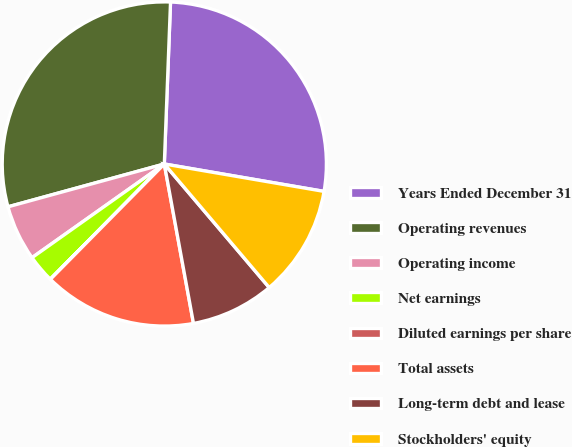<chart> <loc_0><loc_0><loc_500><loc_500><pie_chart><fcel>Years Ended December 31<fcel>Operating revenues<fcel>Operating income<fcel>Net earnings<fcel>Diluted earnings per share<fcel>Total assets<fcel>Long-term debt and lease<fcel>Stockholders' equity<nl><fcel>27.09%<fcel>29.86%<fcel>5.55%<fcel>2.78%<fcel>0.01%<fcel>15.28%<fcel>8.32%<fcel>11.09%<nl></chart> 